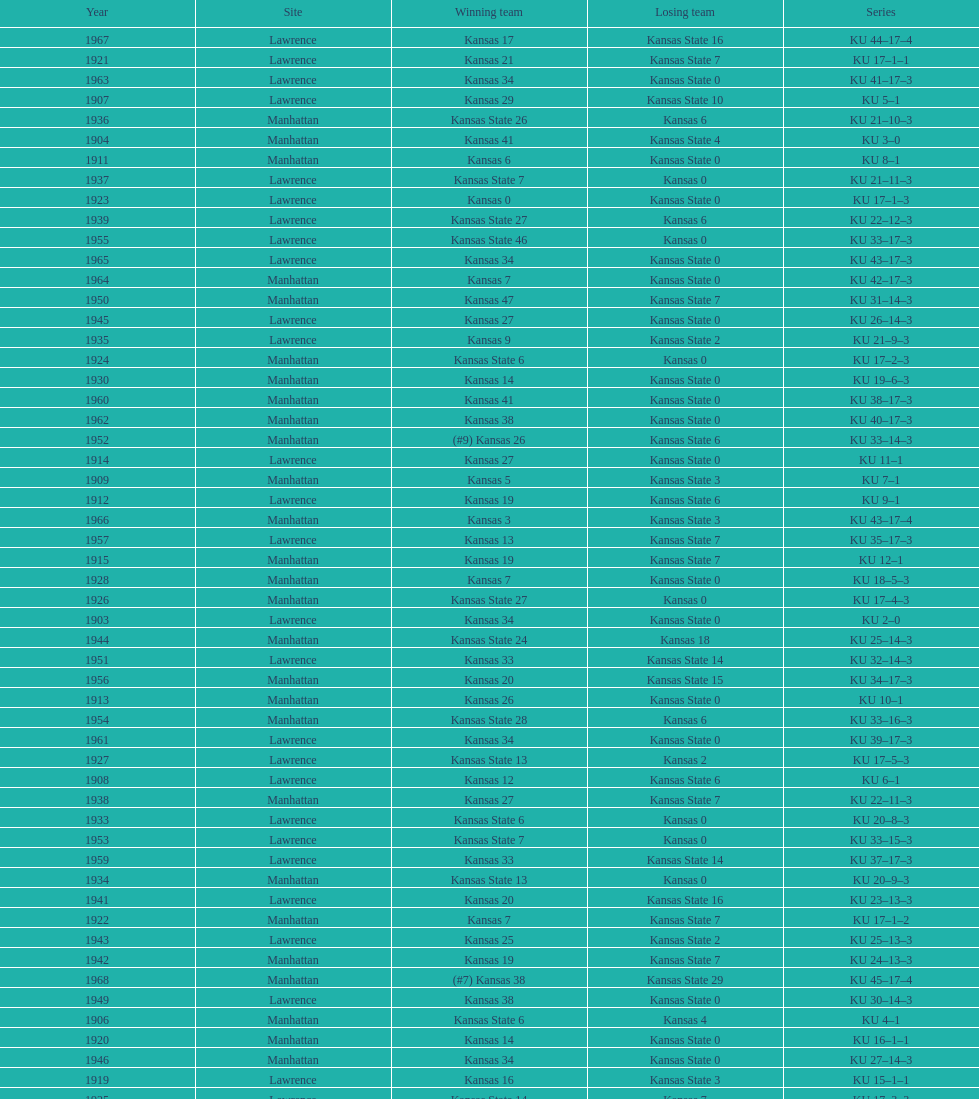Would you mind parsing the complete table? {'header': ['Year', 'Site', 'Winning team', 'Losing team', 'Series'], 'rows': [['1967', 'Lawrence', 'Kansas 17', 'Kansas State 16', 'KU 44–17–4'], ['1921', 'Lawrence', 'Kansas 21', 'Kansas State 7', 'KU 17–1–1'], ['1963', 'Lawrence', 'Kansas 34', 'Kansas State 0', 'KU 41–17–3'], ['1907', 'Lawrence', 'Kansas 29', 'Kansas State 10', 'KU 5–1'], ['1936', 'Manhattan', 'Kansas State 26', 'Kansas 6', 'KU 21–10–3'], ['1904', 'Manhattan', 'Kansas 41', 'Kansas State 4', 'KU 3–0'], ['1911', 'Manhattan', 'Kansas 6', 'Kansas State 0', 'KU 8–1'], ['1937', 'Lawrence', 'Kansas State 7', 'Kansas 0', 'KU 21–11–3'], ['1923', 'Lawrence', 'Kansas 0', 'Kansas State 0', 'KU 17–1–3'], ['1939', 'Lawrence', 'Kansas State 27', 'Kansas 6', 'KU 22–12–3'], ['1955', 'Lawrence', 'Kansas State 46', 'Kansas 0', 'KU 33–17–3'], ['1965', 'Lawrence', 'Kansas 34', 'Kansas State 0', 'KU 43–17–3'], ['1964', 'Manhattan', 'Kansas 7', 'Kansas State 0', 'KU 42–17–3'], ['1950', 'Manhattan', 'Kansas 47', 'Kansas State 7', 'KU 31–14–3'], ['1945', 'Lawrence', 'Kansas 27', 'Kansas State 0', 'KU 26–14–3'], ['1935', 'Lawrence', 'Kansas 9', 'Kansas State 2', 'KU 21–9–3'], ['1924', 'Manhattan', 'Kansas State 6', 'Kansas 0', 'KU 17–2–3'], ['1930', 'Manhattan', 'Kansas 14', 'Kansas State 0', 'KU 19–6–3'], ['1960', 'Manhattan', 'Kansas 41', 'Kansas State 0', 'KU 38–17–3'], ['1962', 'Manhattan', 'Kansas 38', 'Kansas State 0', 'KU 40–17–3'], ['1952', 'Manhattan', '(#9) Kansas 26', 'Kansas State 6', 'KU 33–14–3'], ['1914', 'Lawrence', 'Kansas 27', 'Kansas State 0', 'KU 11–1'], ['1909', 'Manhattan', 'Kansas 5', 'Kansas State 3', 'KU 7–1'], ['1912', 'Lawrence', 'Kansas 19', 'Kansas State 6', 'KU 9–1'], ['1966', 'Manhattan', 'Kansas 3', 'Kansas State 3', 'KU 43–17–4'], ['1957', 'Lawrence', 'Kansas 13', 'Kansas State 7', 'KU 35–17–3'], ['1915', 'Manhattan', 'Kansas 19', 'Kansas State 7', 'KU 12–1'], ['1928', 'Manhattan', 'Kansas 7', 'Kansas State 0', 'KU 18–5–3'], ['1926', 'Manhattan', 'Kansas State 27', 'Kansas 0', 'KU 17–4–3'], ['1903', 'Lawrence', 'Kansas 34', 'Kansas State 0', 'KU 2–0'], ['1944', 'Manhattan', 'Kansas State 24', 'Kansas 18', 'KU 25–14–3'], ['1951', 'Lawrence', 'Kansas 33', 'Kansas State 14', 'KU 32–14–3'], ['1956', 'Manhattan', 'Kansas 20', 'Kansas State 15', 'KU 34–17–3'], ['1913', 'Manhattan', 'Kansas 26', 'Kansas State 0', 'KU 10–1'], ['1954', 'Manhattan', 'Kansas State 28', 'Kansas 6', 'KU 33–16–3'], ['1961', 'Lawrence', 'Kansas 34', 'Kansas State 0', 'KU 39–17–3'], ['1927', 'Lawrence', 'Kansas State 13', 'Kansas 2', 'KU 17–5–3'], ['1908', 'Lawrence', 'Kansas 12', 'Kansas State 6', 'KU 6–1'], ['1938', 'Manhattan', 'Kansas 27', 'Kansas State 7', 'KU 22–11–3'], ['1933', 'Lawrence', 'Kansas State 6', 'Kansas 0', 'KU 20–8–3'], ['1953', 'Lawrence', 'Kansas State 7', 'Kansas 0', 'KU 33–15–3'], ['1959', 'Lawrence', 'Kansas 33', 'Kansas State 14', 'KU 37–17–3'], ['1934', 'Manhattan', 'Kansas State 13', 'Kansas 0', 'KU 20–9–3'], ['1941', 'Lawrence', 'Kansas 20', 'Kansas State 16', 'KU 23–13–3'], ['1922', 'Manhattan', 'Kansas 7', 'Kansas State 7', 'KU 17–1–2'], ['1943', 'Lawrence', 'Kansas 25', 'Kansas State 2', 'KU 25–13–3'], ['1942', 'Manhattan', 'Kansas 19', 'Kansas State 7', 'KU 24–13–3'], ['1968', 'Manhattan', '(#7) Kansas 38', 'Kansas State 29', 'KU 45–17–4'], ['1949', 'Lawrence', 'Kansas 38', 'Kansas State 0', 'KU 30–14–3'], ['1906', 'Manhattan', 'Kansas State 6', 'Kansas 4', 'KU 4–1'], ['1920', 'Manhattan', 'Kansas 14', 'Kansas State 0', 'KU 16–1–1'], ['1946', 'Manhattan', 'Kansas 34', 'Kansas State 0', 'KU 27–14–3'], ['1919', 'Lawrence', 'Kansas 16', 'Kansas State 3', 'KU 15–1–1'], ['1925', 'Lawrence', 'Kansas State 14', 'Kansas 7', 'KU 17–3–3'], ['1958', 'Manhattan', 'Kansas 21', 'Kansas State 12', 'KU 36–17–3'], ['1902', 'Lawrence', 'Kansas 16', 'Kansas State 0', 'KU 1–0'], ['1931', 'Lawrence', 'Kansas State 13', 'Kansas 0', 'KU 19–7–3'], ['1905', 'Lawrence', 'Kansas 28', 'Kansas State 0', 'KU 4–0'], ['1947', 'Lawrence', 'Kansas 55', 'Kansas State 0', 'KU 28–14–3'], ['1929', 'Lawrence', 'Kansas State 6', 'Kansas 0', 'KU 18–6–3'], ['1932', 'Manhattan', 'Kansas 19', 'Kansas State 0', 'KU 20–7–3'], ['1916', 'Lawrence', 'Kansas 0', 'Kansas State 0', 'KU 12–1–1'], ['1918', 'Lawrence', 'Kansas 13', 'Kansas State 7', 'KU 14–1–1'], ['1948', 'Manhattan', 'Kansas 20', 'Kansas State 14', 'KU 29–14–3'], ['1917', 'Manhattan', 'Kansas 9', 'Kansas State 0', 'KU 13–1–1'], ['1940', 'Manhattan', 'Kansas State 20', 'Kansas 0', 'KU 22–13–3']]} Before 1950 what was the most points kansas scored? 55. 